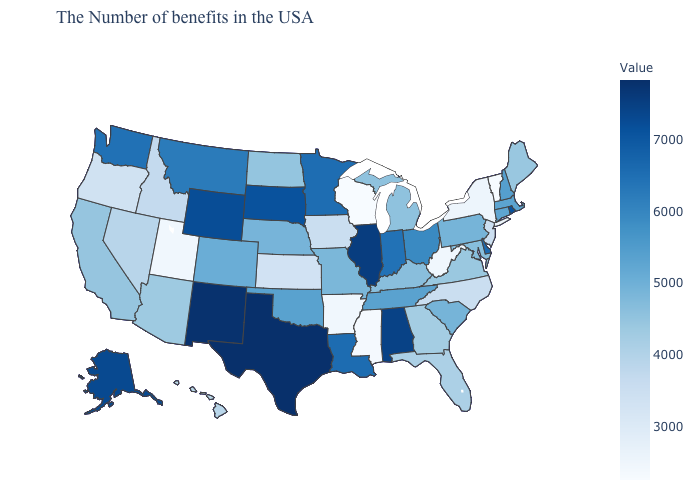Which states hav the highest value in the MidWest?
Answer briefly. Illinois. Which states have the lowest value in the USA?
Quick response, please. Wisconsin. Among the states that border Delaware , which have the highest value?
Keep it brief. Pennsylvania. Which states hav the highest value in the West?
Short answer required. New Mexico. Does Pennsylvania have a higher value than New York?
Give a very brief answer. Yes. Does Georgia have a higher value than Alaska?
Be succinct. No. Among the states that border Arizona , which have the lowest value?
Write a very short answer. Utah. Which states have the highest value in the USA?
Keep it brief. Texas. Which states have the lowest value in the MidWest?
Give a very brief answer. Wisconsin. 